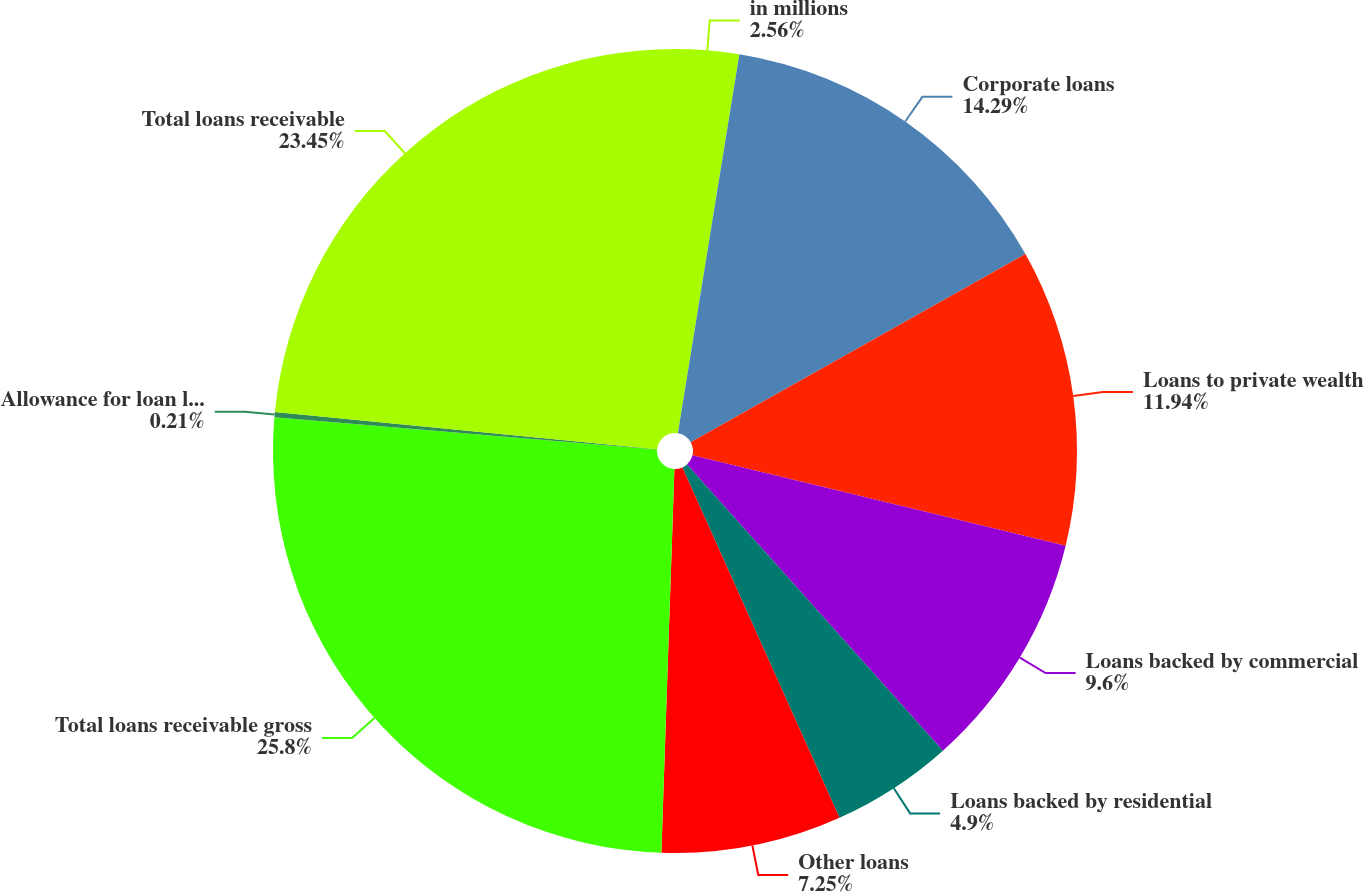Convert chart. <chart><loc_0><loc_0><loc_500><loc_500><pie_chart><fcel>in millions<fcel>Corporate loans<fcel>Loans to private wealth<fcel>Loans backed by commercial<fcel>Loans backed by residential<fcel>Other loans<fcel>Total loans receivable gross<fcel>Allowance for loan losses<fcel>Total loans receivable<nl><fcel>2.56%<fcel>14.29%<fcel>11.94%<fcel>9.6%<fcel>4.9%<fcel>7.25%<fcel>25.8%<fcel>0.21%<fcel>23.45%<nl></chart> 